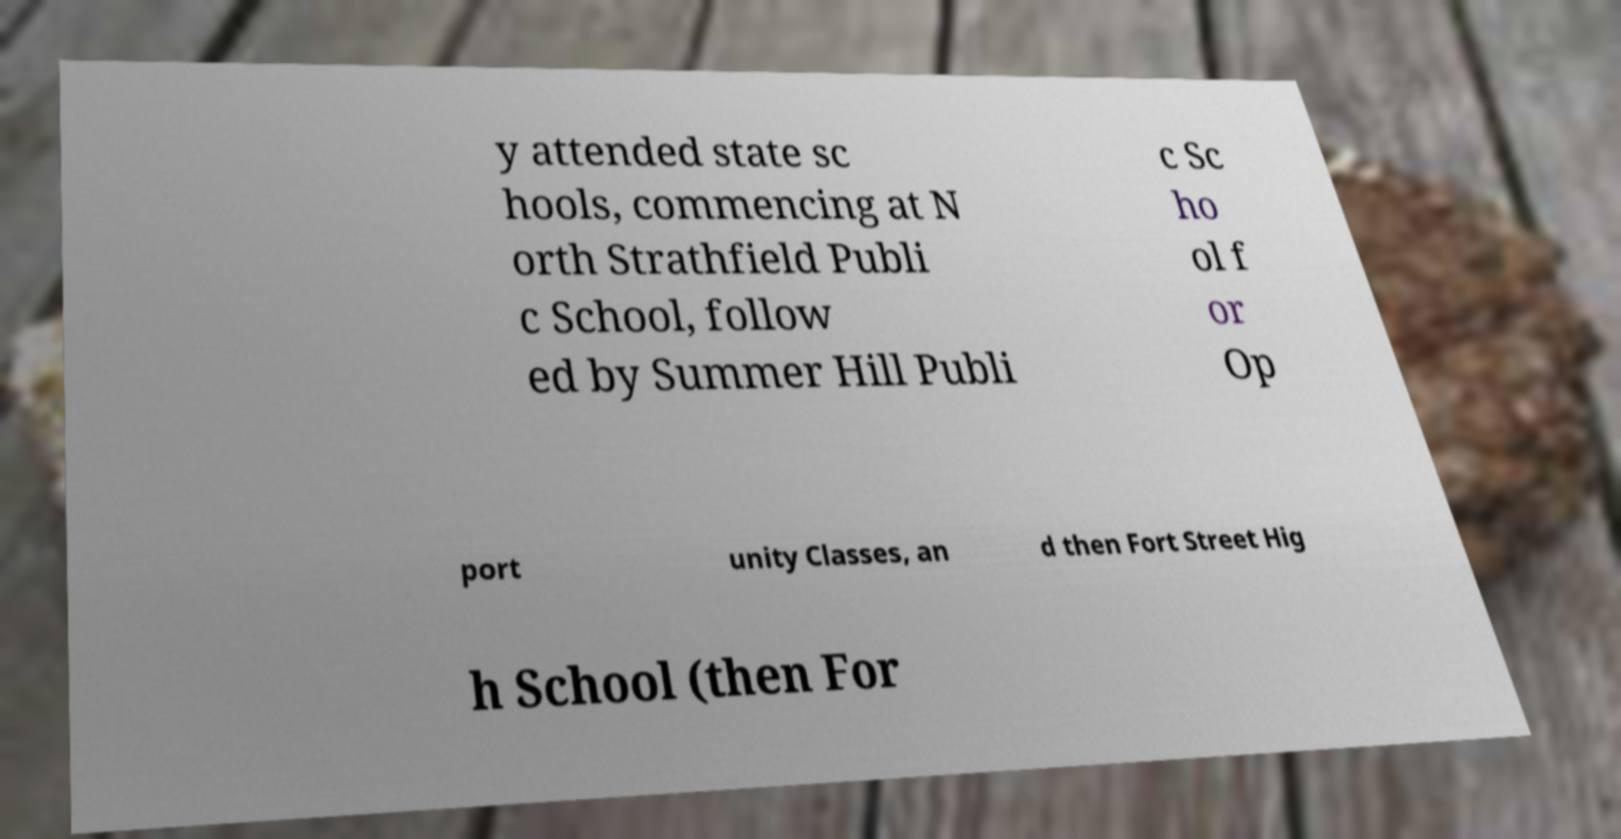Please read and relay the text visible in this image. What does it say? y attended state sc hools, commencing at N orth Strathfield Publi c School, follow ed by Summer Hill Publi c Sc ho ol f or Op port unity Classes, an d then Fort Street Hig h School (then For 